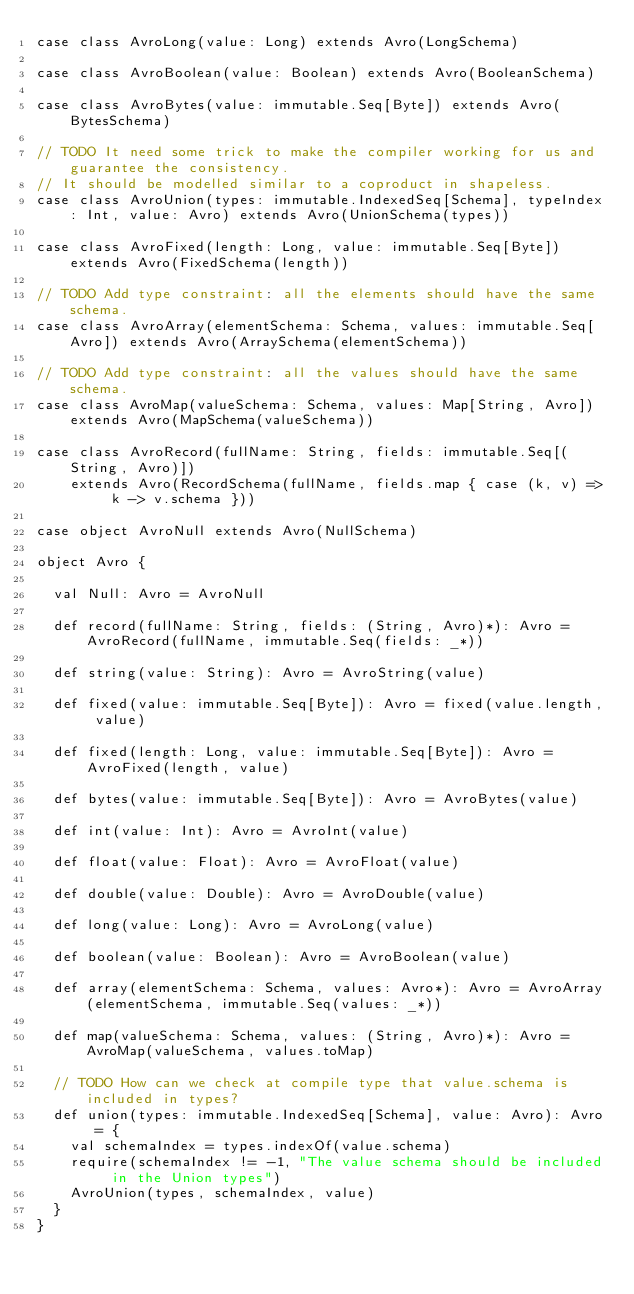<code> <loc_0><loc_0><loc_500><loc_500><_Scala_>case class AvroLong(value: Long) extends Avro(LongSchema)

case class AvroBoolean(value: Boolean) extends Avro(BooleanSchema)

case class AvroBytes(value: immutable.Seq[Byte]) extends Avro(BytesSchema)

// TODO It need some trick to make the compiler working for us and guarantee the consistency.
// It should be modelled similar to a coproduct in shapeless.
case class AvroUnion(types: immutable.IndexedSeq[Schema], typeIndex: Int, value: Avro) extends Avro(UnionSchema(types))

case class AvroFixed(length: Long, value: immutable.Seq[Byte]) extends Avro(FixedSchema(length))

// TODO Add type constraint: all the elements should have the same schema.
case class AvroArray(elementSchema: Schema, values: immutable.Seq[Avro]) extends Avro(ArraySchema(elementSchema))

// TODO Add type constraint: all the values should have the same schema.
case class AvroMap(valueSchema: Schema, values: Map[String, Avro]) extends Avro(MapSchema(valueSchema))

case class AvroRecord(fullName: String, fields: immutable.Seq[(String, Avro)])
    extends Avro(RecordSchema(fullName, fields.map { case (k, v) => k -> v.schema }))

case object AvroNull extends Avro(NullSchema)

object Avro {

  val Null: Avro = AvroNull

  def record(fullName: String, fields: (String, Avro)*): Avro = AvroRecord(fullName, immutable.Seq(fields: _*))

  def string(value: String): Avro = AvroString(value)

  def fixed(value: immutable.Seq[Byte]): Avro = fixed(value.length, value)

  def fixed(length: Long, value: immutable.Seq[Byte]): Avro = AvroFixed(length, value)

  def bytes(value: immutable.Seq[Byte]): Avro = AvroBytes(value)

  def int(value: Int): Avro = AvroInt(value)

  def float(value: Float): Avro = AvroFloat(value)

  def double(value: Double): Avro = AvroDouble(value)

  def long(value: Long): Avro = AvroLong(value)

  def boolean(value: Boolean): Avro = AvroBoolean(value)

  def array(elementSchema: Schema, values: Avro*): Avro = AvroArray(elementSchema, immutable.Seq(values: _*))

  def map(valueSchema: Schema, values: (String, Avro)*): Avro = AvroMap(valueSchema, values.toMap)

  // TODO How can we check at compile type that value.schema is included in types?
  def union(types: immutable.IndexedSeq[Schema], value: Avro): Avro = {
    val schemaIndex = types.indexOf(value.schema)
    require(schemaIndex != -1, "The value schema should be included in the Union types")
    AvroUnion(types, schemaIndex, value)
  }
}
</code> 